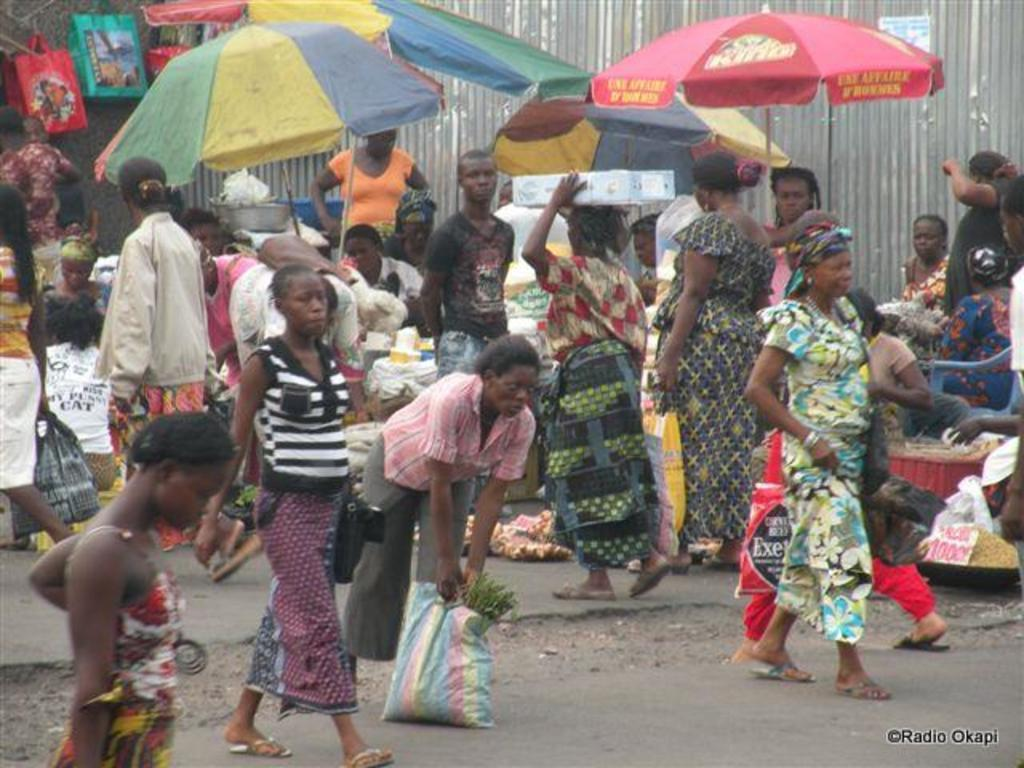What can be seen on the road in the image? There are persons on the road in the image. What type of items are visible in the image besides the persons? There are vegetables, umbrellas, and bags in the image. What is the background of the image? There is a wall in the image. What type of tank is visible in the image? There is no tank present in the image. What activity are the persons engaged in while holding the vegetables and umbrellas? The image does not provide information about the activity the persons are engaged in. 